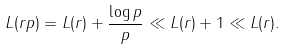Convert formula to latex. <formula><loc_0><loc_0><loc_500><loc_500>L ( r p ) = L ( r ) + \frac { \log p } { p } \ll L ( r ) + 1 \ll L ( r ) .</formula> 